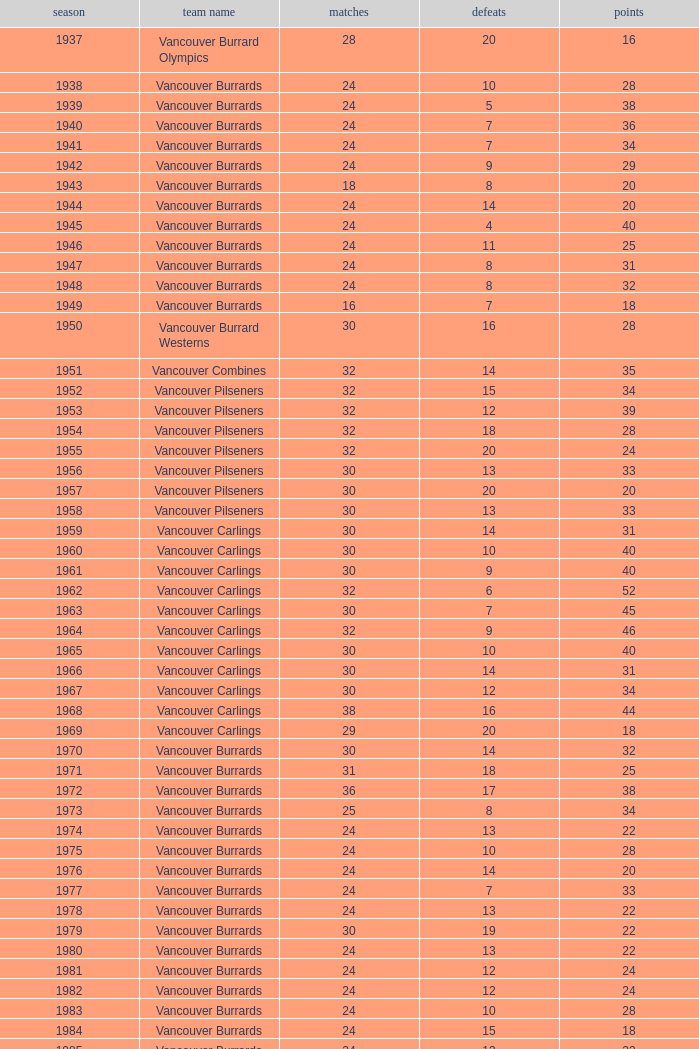What's the total number of points when the vancouver carlings have fewer than 12 losses and more than 32 games? 0.0. 